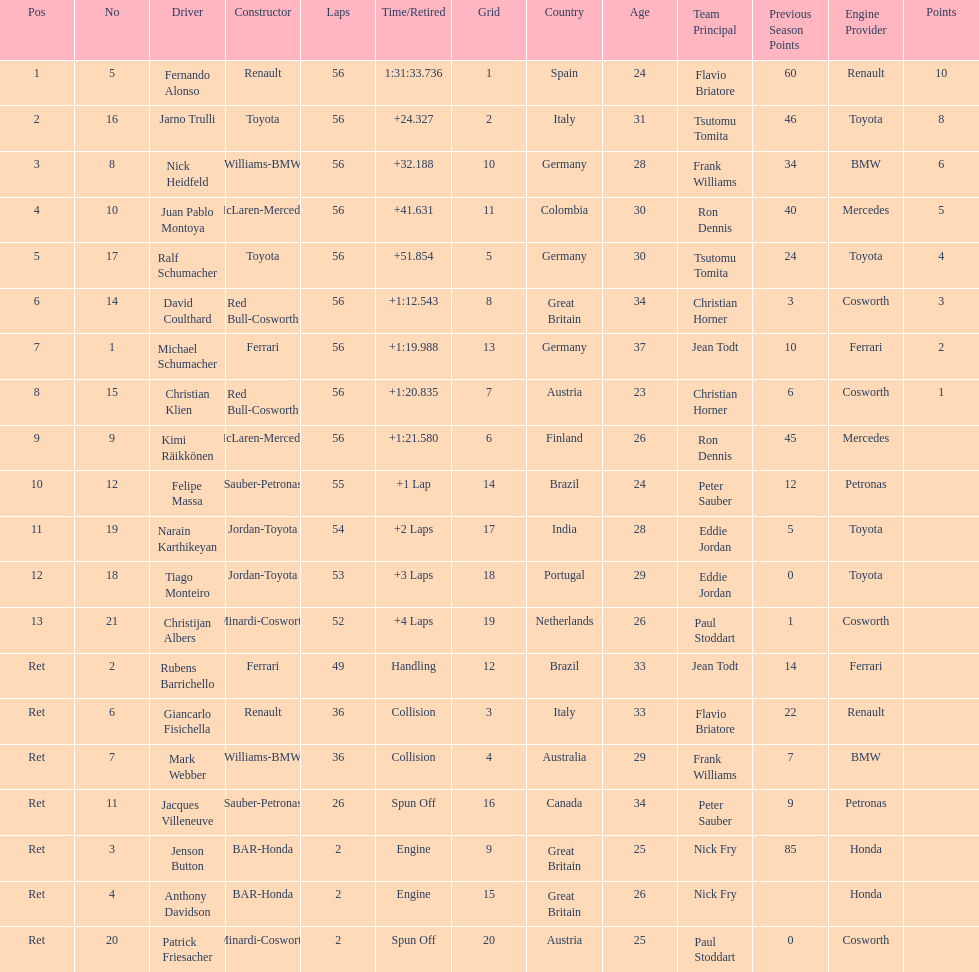How many bmws concluded before webber? 1. 